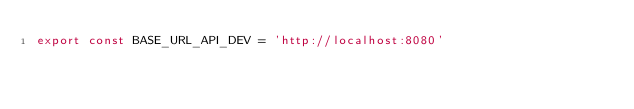<code> <loc_0><loc_0><loc_500><loc_500><_JavaScript_>export const BASE_URL_API_DEV = 'http://localhost:8080'</code> 